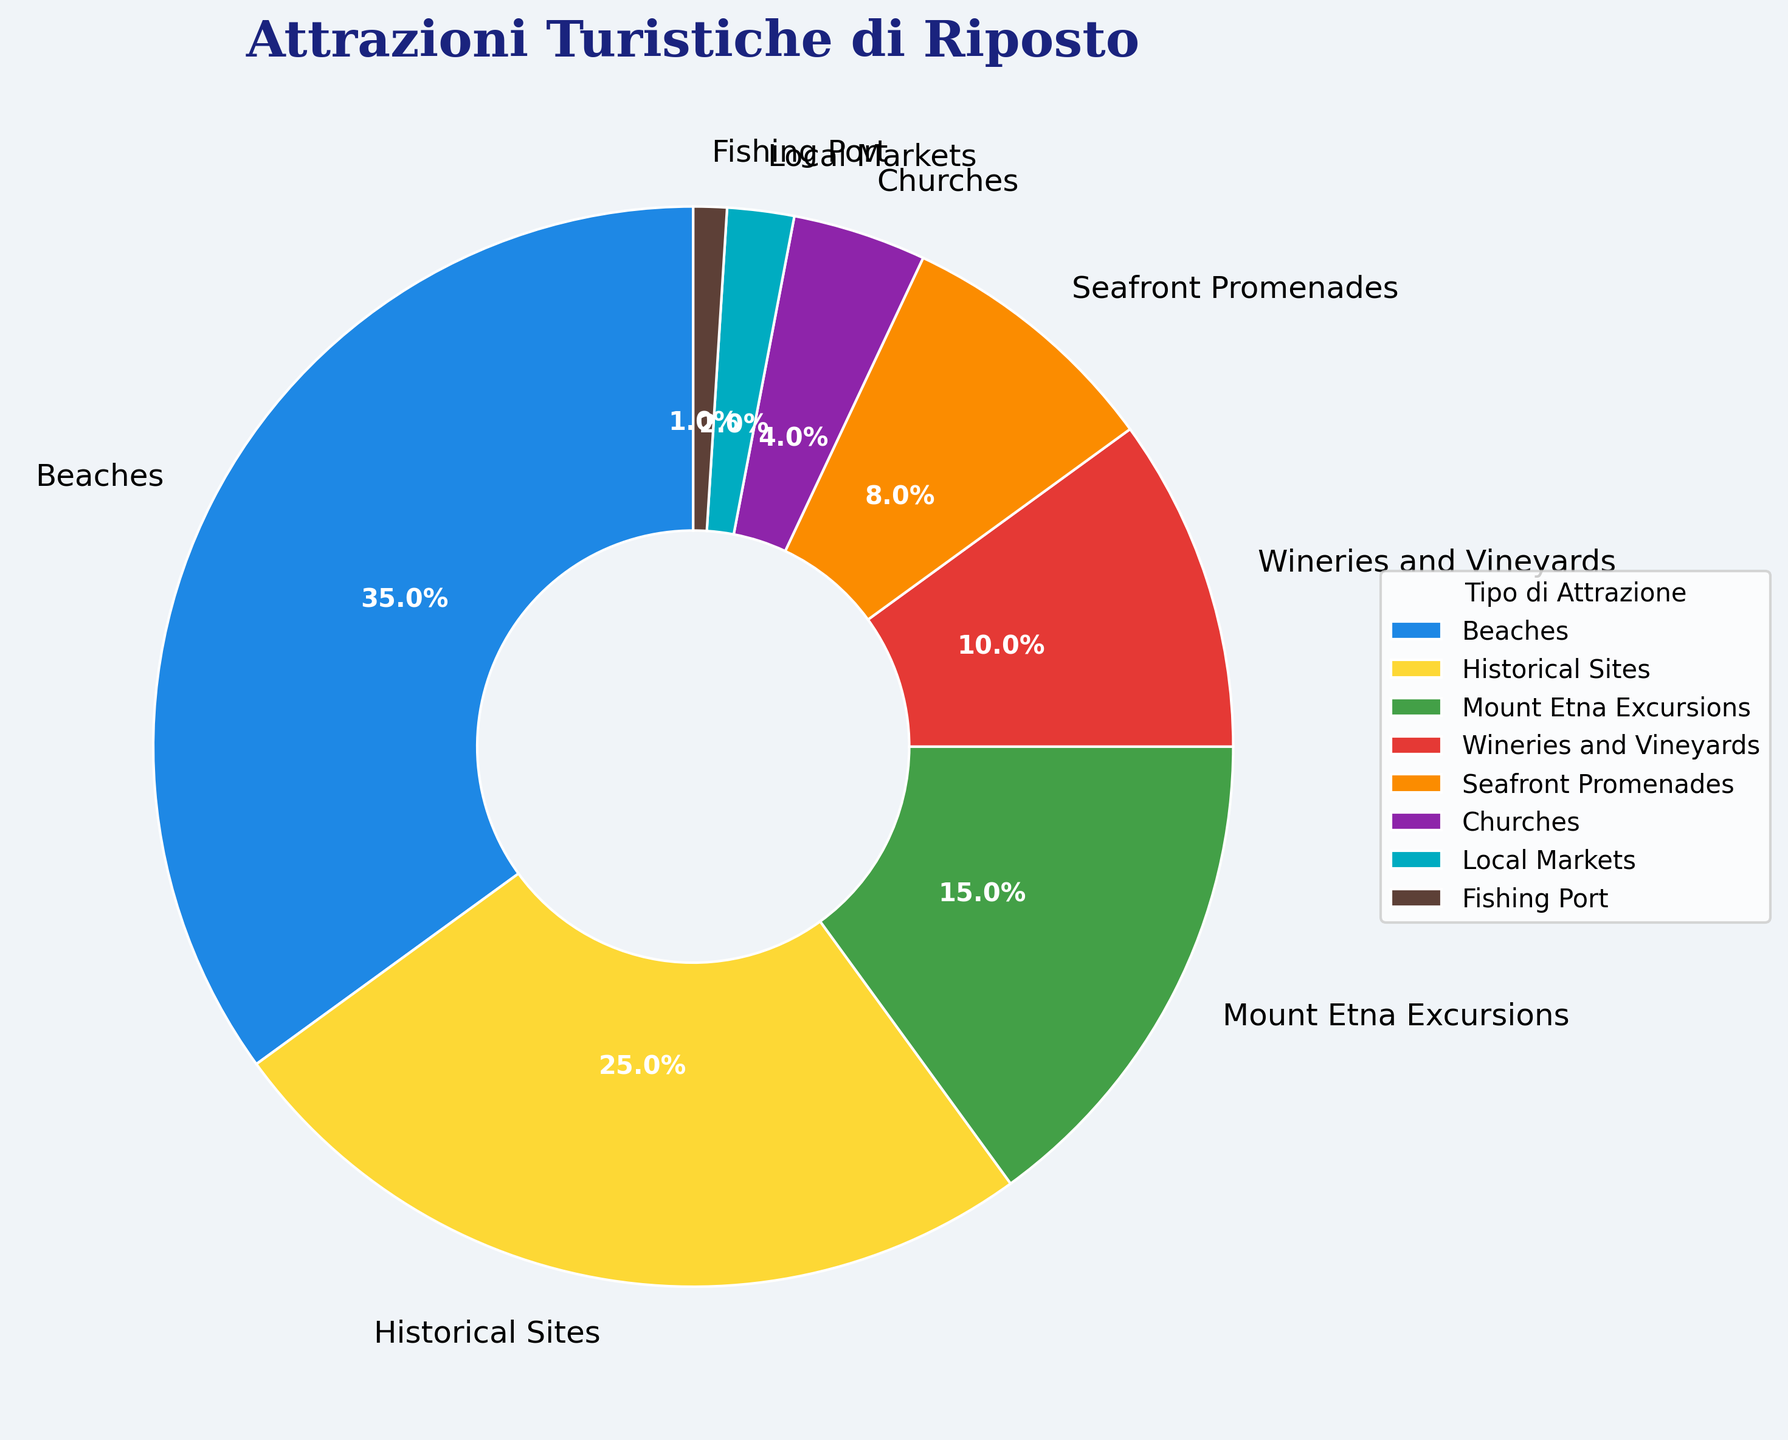Which type of tourist attraction is the most prevalent in Riposto? To identify the most prevalent tourist attraction, look for the slice with the largest percentage in the pie chart. The largest slice corresponds to "Beaches" with 35%.
Answer: Beaches What is the combined percentage of Wineries and Vineyards and Seafront Promenades? Add the percentages of Wineries and Vineyards (10%) and Seafront Promenades (8%). The sum is 10% + 8% = 18%.
Answer: 18% How much more prevalent are Historical Sites compared to Mount Etna Excursions? Subtract the percentage of Mount Etna Excursions (15%) from the percentage of Historical Sites (25%). The difference is 25% - 15% = 10%.
Answer: 10% Which categories are represented by the smallest slices in the pie chart? Identify the smallest slices by checking the percentages; the smallest categories are "Fishing Port" (1%) and "Local Markets" (2%).
Answer: Fishing Port, Local Markets What is the total percentage of nature-related attractions (Beaches, Nature Parks, and Mount Etna Excursions)? Add the percentages of Beaches (35%), Nature Parks (not listed, assumed to be 0%), and Mount Etna Excursions (15%). The sum is 35% + 15% = 50%.
Answer: 50% Are there more Historical Sites or Churches in Riposto, and by how much? Comparing Historical Sites (25%) and Churches (4%), subtract the percentage of Churches from Historical Sites: 25% - 4% = 21%.
Answer: Historical Sites by 21% What is the percentage difference between Seafront Promenades and Local Markets? Subtract the percentage of Local Markets (2%) from the percentage of Seafront Promenades (8%). The difference is 8% - 2% = 6%.
Answer: 6% Is the percentage of Churches and Local Markets combined greater than that of Mount Etna Excursions? Add the percentages of Churches (4%) and Local Markets (2%): 4% + 2% = 6%. Compare this to Mount Etna Excursions (15%); 6% is less than 15%.
Answer: No 